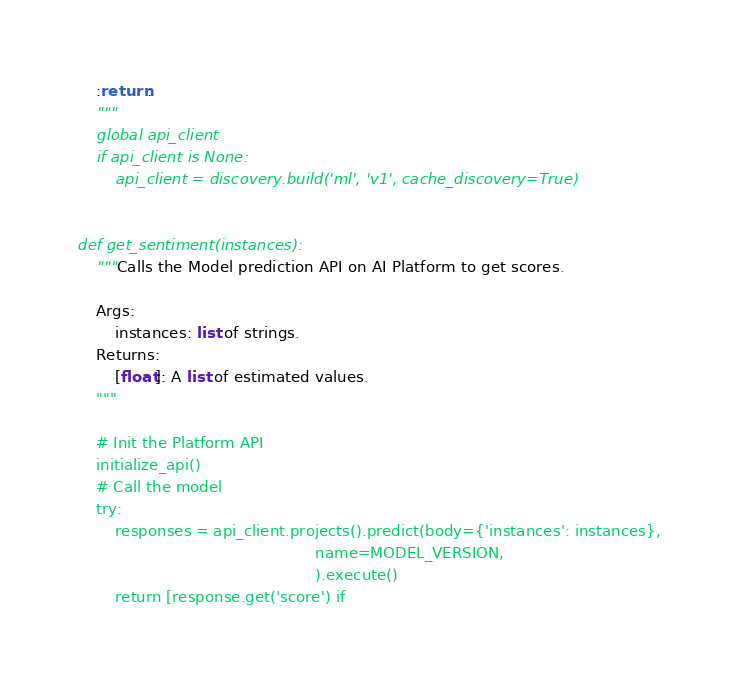Convert code to text. <code><loc_0><loc_0><loc_500><loc_500><_Python_>    :return:
    """
    global api_client
    if api_client is None:
        api_client = discovery.build('ml', 'v1', cache_discovery=True)


def get_sentiment(instances):
    """Calls the Model prediction API on AI Platform to get scores.

    Args:
        instances: list of strings.
    Returns:
        [float]: A list of estimated values.
    """

    # Init the Platform API
    initialize_api()
    # Call the model
    try:
        responses = api_client.projects().predict(body={'instances': instances},
                                                  name=MODEL_VERSION,
                                                  ).execute()
        return [response.get('score') if</code> 